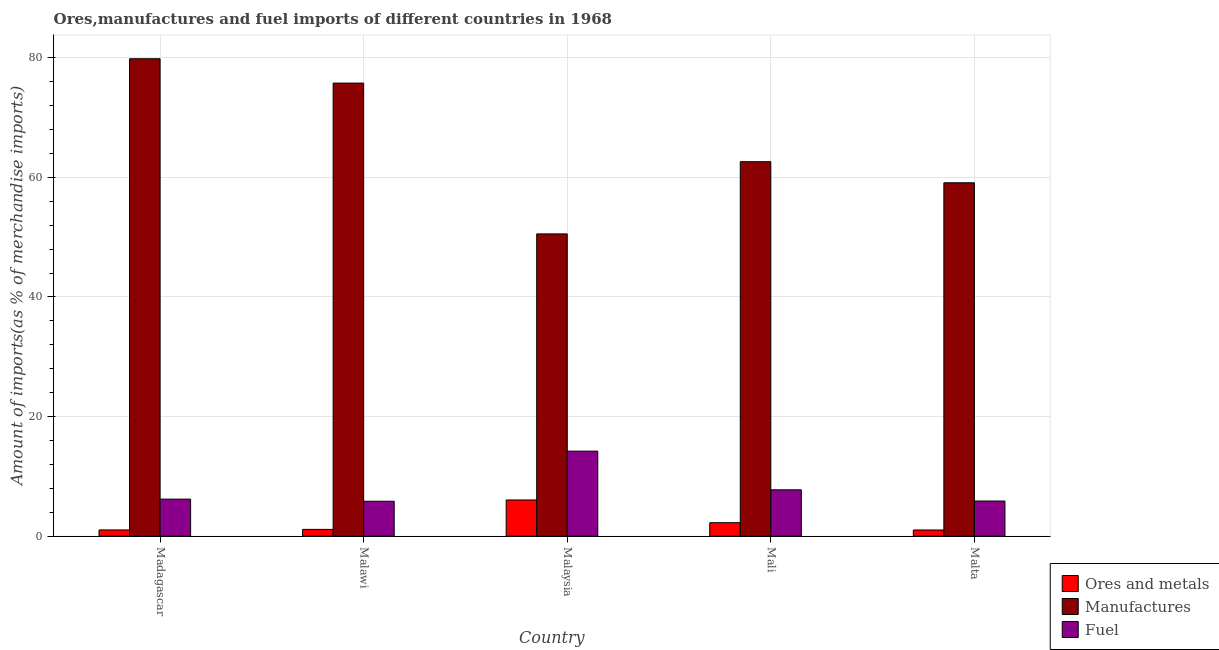How many different coloured bars are there?
Offer a very short reply. 3. How many bars are there on the 2nd tick from the left?
Provide a succinct answer. 3. How many bars are there on the 5th tick from the right?
Keep it short and to the point. 3. What is the label of the 4th group of bars from the left?
Your answer should be compact. Mali. What is the percentage of ores and metals imports in Malawi?
Provide a short and direct response. 1.15. Across all countries, what is the maximum percentage of ores and metals imports?
Your answer should be very brief. 6.06. Across all countries, what is the minimum percentage of ores and metals imports?
Your response must be concise. 1.05. In which country was the percentage of fuel imports maximum?
Make the answer very short. Malaysia. In which country was the percentage of ores and metals imports minimum?
Give a very brief answer. Malta. What is the total percentage of manufactures imports in the graph?
Make the answer very short. 327.84. What is the difference between the percentage of fuel imports in Madagascar and that in Malta?
Provide a short and direct response. 0.32. What is the difference between the percentage of ores and metals imports in Madagascar and the percentage of manufactures imports in Malta?
Ensure brevity in your answer.  -58.04. What is the average percentage of fuel imports per country?
Ensure brevity in your answer.  7.99. What is the difference between the percentage of fuel imports and percentage of manufactures imports in Malta?
Make the answer very short. -53.2. In how many countries, is the percentage of fuel imports greater than 32 %?
Offer a terse response. 0. What is the ratio of the percentage of ores and metals imports in Madagascar to that in Malta?
Offer a very short reply. 1.01. Is the percentage of ores and metals imports in Madagascar less than that in Mali?
Provide a succinct answer. Yes. What is the difference between the highest and the second highest percentage of manufactures imports?
Your response must be concise. 4.07. What is the difference between the highest and the lowest percentage of fuel imports?
Keep it short and to the point. 8.38. In how many countries, is the percentage of ores and metals imports greater than the average percentage of ores and metals imports taken over all countries?
Provide a short and direct response. 1. Is the sum of the percentage of ores and metals imports in Madagascar and Malaysia greater than the maximum percentage of manufactures imports across all countries?
Keep it short and to the point. No. What does the 1st bar from the left in Malawi represents?
Ensure brevity in your answer.  Ores and metals. What does the 3rd bar from the right in Mali represents?
Your answer should be very brief. Ores and metals. Is it the case that in every country, the sum of the percentage of ores and metals imports and percentage of manufactures imports is greater than the percentage of fuel imports?
Offer a terse response. Yes. How many bars are there?
Keep it short and to the point. 15. Are all the bars in the graph horizontal?
Provide a succinct answer. No. How many countries are there in the graph?
Offer a terse response. 5. Does the graph contain grids?
Your response must be concise. Yes. How are the legend labels stacked?
Make the answer very short. Vertical. What is the title of the graph?
Your answer should be very brief. Ores,manufactures and fuel imports of different countries in 1968. What is the label or title of the Y-axis?
Provide a short and direct response. Amount of imports(as % of merchandise imports). What is the Amount of imports(as % of merchandise imports) of Ores and metals in Madagascar?
Provide a short and direct response. 1.06. What is the Amount of imports(as % of merchandise imports) in Manufactures in Madagascar?
Ensure brevity in your answer.  79.83. What is the Amount of imports(as % of merchandise imports) in Fuel in Madagascar?
Offer a very short reply. 6.21. What is the Amount of imports(as % of merchandise imports) in Ores and metals in Malawi?
Give a very brief answer. 1.15. What is the Amount of imports(as % of merchandise imports) of Manufactures in Malawi?
Provide a short and direct response. 75.76. What is the Amount of imports(as % of merchandise imports) of Fuel in Malawi?
Provide a short and direct response. 5.85. What is the Amount of imports(as % of merchandise imports) of Ores and metals in Malaysia?
Offer a terse response. 6.06. What is the Amount of imports(as % of merchandise imports) in Manufactures in Malaysia?
Ensure brevity in your answer.  50.55. What is the Amount of imports(as % of merchandise imports) in Fuel in Malaysia?
Offer a very short reply. 14.23. What is the Amount of imports(as % of merchandise imports) in Ores and metals in Mali?
Your answer should be very brief. 2.27. What is the Amount of imports(as % of merchandise imports) of Manufactures in Mali?
Your answer should be very brief. 62.62. What is the Amount of imports(as % of merchandise imports) in Fuel in Mali?
Offer a very short reply. 7.76. What is the Amount of imports(as % of merchandise imports) of Ores and metals in Malta?
Give a very brief answer. 1.05. What is the Amount of imports(as % of merchandise imports) of Manufactures in Malta?
Your answer should be compact. 59.09. What is the Amount of imports(as % of merchandise imports) of Fuel in Malta?
Your response must be concise. 5.89. Across all countries, what is the maximum Amount of imports(as % of merchandise imports) of Ores and metals?
Give a very brief answer. 6.06. Across all countries, what is the maximum Amount of imports(as % of merchandise imports) of Manufactures?
Give a very brief answer. 79.83. Across all countries, what is the maximum Amount of imports(as % of merchandise imports) of Fuel?
Offer a very short reply. 14.23. Across all countries, what is the minimum Amount of imports(as % of merchandise imports) of Ores and metals?
Your answer should be compact. 1.05. Across all countries, what is the minimum Amount of imports(as % of merchandise imports) in Manufactures?
Offer a terse response. 50.55. Across all countries, what is the minimum Amount of imports(as % of merchandise imports) in Fuel?
Provide a succinct answer. 5.85. What is the total Amount of imports(as % of merchandise imports) in Ores and metals in the graph?
Your answer should be very brief. 11.58. What is the total Amount of imports(as % of merchandise imports) in Manufactures in the graph?
Your response must be concise. 327.84. What is the total Amount of imports(as % of merchandise imports) of Fuel in the graph?
Your answer should be compact. 39.94. What is the difference between the Amount of imports(as % of merchandise imports) of Ores and metals in Madagascar and that in Malawi?
Offer a terse response. -0.09. What is the difference between the Amount of imports(as % of merchandise imports) of Manufactures in Madagascar and that in Malawi?
Give a very brief answer. 4.07. What is the difference between the Amount of imports(as % of merchandise imports) of Fuel in Madagascar and that in Malawi?
Ensure brevity in your answer.  0.36. What is the difference between the Amount of imports(as % of merchandise imports) of Ores and metals in Madagascar and that in Malaysia?
Offer a very short reply. -5.01. What is the difference between the Amount of imports(as % of merchandise imports) in Manufactures in Madagascar and that in Malaysia?
Your answer should be very brief. 29.28. What is the difference between the Amount of imports(as % of merchandise imports) in Fuel in Madagascar and that in Malaysia?
Ensure brevity in your answer.  -8.02. What is the difference between the Amount of imports(as % of merchandise imports) of Ores and metals in Madagascar and that in Mali?
Provide a succinct answer. -1.21. What is the difference between the Amount of imports(as % of merchandise imports) of Manufactures in Madagascar and that in Mali?
Your answer should be compact. 17.21. What is the difference between the Amount of imports(as % of merchandise imports) of Fuel in Madagascar and that in Mali?
Your answer should be compact. -1.55. What is the difference between the Amount of imports(as % of merchandise imports) of Ores and metals in Madagascar and that in Malta?
Make the answer very short. 0.01. What is the difference between the Amount of imports(as % of merchandise imports) of Manufactures in Madagascar and that in Malta?
Give a very brief answer. 20.73. What is the difference between the Amount of imports(as % of merchandise imports) in Fuel in Madagascar and that in Malta?
Give a very brief answer. 0.32. What is the difference between the Amount of imports(as % of merchandise imports) in Ores and metals in Malawi and that in Malaysia?
Offer a terse response. -4.92. What is the difference between the Amount of imports(as % of merchandise imports) of Manufactures in Malawi and that in Malaysia?
Offer a terse response. 25.21. What is the difference between the Amount of imports(as % of merchandise imports) of Fuel in Malawi and that in Malaysia?
Provide a short and direct response. -8.38. What is the difference between the Amount of imports(as % of merchandise imports) in Ores and metals in Malawi and that in Mali?
Give a very brief answer. -1.12. What is the difference between the Amount of imports(as % of merchandise imports) in Manufactures in Malawi and that in Mali?
Give a very brief answer. 13.14. What is the difference between the Amount of imports(as % of merchandise imports) of Fuel in Malawi and that in Mali?
Offer a terse response. -1.91. What is the difference between the Amount of imports(as % of merchandise imports) of Ores and metals in Malawi and that in Malta?
Provide a short and direct response. 0.1. What is the difference between the Amount of imports(as % of merchandise imports) in Manufactures in Malawi and that in Malta?
Offer a terse response. 16.66. What is the difference between the Amount of imports(as % of merchandise imports) in Fuel in Malawi and that in Malta?
Offer a very short reply. -0.04. What is the difference between the Amount of imports(as % of merchandise imports) of Ores and metals in Malaysia and that in Mali?
Provide a short and direct response. 3.8. What is the difference between the Amount of imports(as % of merchandise imports) in Manufactures in Malaysia and that in Mali?
Your answer should be very brief. -12.07. What is the difference between the Amount of imports(as % of merchandise imports) in Fuel in Malaysia and that in Mali?
Give a very brief answer. 6.47. What is the difference between the Amount of imports(as % of merchandise imports) of Ores and metals in Malaysia and that in Malta?
Offer a very short reply. 5.02. What is the difference between the Amount of imports(as % of merchandise imports) in Manufactures in Malaysia and that in Malta?
Keep it short and to the point. -8.55. What is the difference between the Amount of imports(as % of merchandise imports) of Fuel in Malaysia and that in Malta?
Your answer should be compact. 8.34. What is the difference between the Amount of imports(as % of merchandise imports) in Ores and metals in Mali and that in Malta?
Provide a succinct answer. 1.22. What is the difference between the Amount of imports(as % of merchandise imports) of Manufactures in Mali and that in Malta?
Provide a succinct answer. 3.52. What is the difference between the Amount of imports(as % of merchandise imports) of Fuel in Mali and that in Malta?
Keep it short and to the point. 1.87. What is the difference between the Amount of imports(as % of merchandise imports) of Ores and metals in Madagascar and the Amount of imports(as % of merchandise imports) of Manufactures in Malawi?
Give a very brief answer. -74.7. What is the difference between the Amount of imports(as % of merchandise imports) of Ores and metals in Madagascar and the Amount of imports(as % of merchandise imports) of Fuel in Malawi?
Your answer should be compact. -4.79. What is the difference between the Amount of imports(as % of merchandise imports) of Manufactures in Madagascar and the Amount of imports(as % of merchandise imports) of Fuel in Malawi?
Your answer should be compact. 73.98. What is the difference between the Amount of imports(as % of merchandise imports) of Ores and metals in Madagascar and the Amount of imports(as % of merchandise imports) of Manufactures in Malaysia?
Your answer should be compact. -49.49. What is the difference between the Amount of imports(as % of merchandise imports) in Ores and metals in Madagascar and the Amount of imports(as % of merchandise imports) in Fuel in Malaysia?
Provide a short and direct response. -13.17. What is the difference between the Amount of imports(as % of merchandise imports) in Manufactures in Madagascar and the Amount of imports(as % of merchandise imports) in Fuel in Malaysia?
Your answer should be compact. 65.6. What is the difference between the Amount of imports(as % of merchandise imports) in Ores and metals in Madagascar and the Amount of imports(as % of merchandise imports) in Manufactures in Mali?
Your answer should be compact. -61.56. What is the difference between the Amount of imports(as % of merchandise imports) of Ores and metals in Madagascar and the Amount of imports(as % of merchandise imports) of Fuel in Mali?
Provide a succinct answer. -6.7. What is the difference between the Amount of imports(as % of merchandise imports) of Manufactures in Madagascar and the Amount of imports(as % of merchandise imports) of Fuel in Mali?
Provide a short and direct response. 72.07. What is the difference between the Amount of imports(as % of merchandise imports) in Ores and metals in Madagascar and the Amount of imports(as % of merchandise imports) in Manufactures in Malta?
Provide a short and direct response. -58.04. What is the difference between the Amount of imports(as % of merchandise imports) in Ores and metals in Madagascar and the Amount of imports(as % of merchandise imports) in Fuel in Malta?
Provide a short and direct response. -4.83. What is the difference between the Amount of imports(as % of merchandise imports) of Manufactures in Madagascar and the Amount of imports(as % of merchandise imports) of Fuel in Malta?
Ensure brevity in your answer.  73.94. What is the difference between the Amount of imports(as % of merchandise imports) of Ores and metals in Malawi and the Amount of imports(as % of merchandise imports) of Manufactures in Malaysia?
Provide a succinct answer. -49.4. What is the difference between the Amount of imports(as % of merchandise imports) of Ores and metals in Malawi and the Amount of imports(as % of merchandise imports) of Fuel in Malaysia?
Your response must be concise. -13.08. What is the difference between the Amount of imports(as % of merchandise imports) in Manufactures in Malawi and the Amount of imports(as % of merchandise imports) in Fuel in Malaysia?
Keep it short and to the point. 61.53. What is the difference between the Amount of imports(as % of merchandise imports) in Ores and metals in Malawi and the Amount of imports(as % of merchandise imports) in Manufactures in Mali?
Keep it short and to the point. -61.47. What is the difference between the Amount of imports(as % of merchandise imports) of Ores and metals in Malawi and the Amount of imports(as % of merchandise imports) of Fuel in Mali?
Ensure brevity in your answer.  -6.62. What is the difference between the Amount of imports(as % of merchandise imports) of Manufactures in Malawi and the Amount of imports(as % of merchandise imports) of Fuel in Mali?
Make the answer very short. 68. What is the difference between the Amount of imports(as % of merchandise imports) of Ores and metals in Malawi and the Amount of imports(as % of merchandise imports) of Manufactures in Malta?
Give a very brief answer. -57.95. What is the difference between the Amount of imports(as % of merchandise imports) of Ores and metals in Malawi and the Amount of imports(as % of merchandise imports) of Fuel in Malta?
Offer a very short reply. -4.74. What is the difference between the Amount of imports(as % of merchandise imports) of Manufactures in Malawi and the Amount of imports(as % of merchandise imports) of Fuel in Malta?
Your response must be concise. 69.87. What is the difference between the Amount of imports(as % of merchandise imports) of Ores and metals in Malaysia and the Amount of imports(as % of merchandise imports) of Manufactures in Mali?
Keep it short and to the point. -56.55. What is the difference between the Amount of imports(as % of merchandise imports) in Ores and metals in Malaysia and the Amount of imports(as % of merchandise imports) in Fuel in Mali?
Provide a short and direct response. -1.7. What is the difference between the Amount of imports(as % of merchandise imports) of Manufactures in Malaysia and the Amount of imports(as % of merchandise imports) of Fuel in Mali?
Provide a succinct answer. 42.78. What is the difference between the Amount of imports(as % of merchandise imports) of Ores and metals in Malaysia and the Amount of imports(as % of merchandise imports) of Manufactures in Malta?
Provide a short and direct response. -53.03. What is the difference between the Amount of imports(as % of merchandise imports) of Ores and metals in Malaysia and the Amount of imports(as % of merchandise imports) of Fuel in Malta?
Provide a short and direct response. 0.17. What is the difference between the Amount of imports(as % of merchandise imports) of Manufactures in Malaysia and the Amount of imports(as % of merchandise imports) of Fuel in Malta?
Your answer should be very brief. 44.66. What is the difference between the Amount of imports(as % of merchandise imports) of Ores and metals in Mali and the Amount of imports(as % of merchandise imports) of Manufactures in Malta?
Make the answer very short. -56.83. What is the difference between the Amount of imports(as % of merchandise imports) of Ores and metals in Mali and the Amount of imports(as % of merchandise imports) of Fuel in Malta?
Keep it short and to the point. -3.62. What is the difference between the Amount of imports(as % of merchandise imports) in Manufactures in Mali and the Amount of imports(as % of merchandise imports) in Fuel in Malta?
Provide a short and direct response. 56.73. What is the average Amount of imports(as % of merchandise imports) of Ores and metals per country?
Provide a succinct answer. 2.32. What is the average Amount of imports(as % of merchandise imports) in Manufactures per country?
Your response must be concise. 65.57. What is the average Amount of imports(as % of merchandise imports) of Fuel per country?
Your answer should be compact. 7.99. What is the difference between the Amount of imports(as % of merchandise imports) in Ores and metals and Amount of imports(as % of merchandise imports) in Manufactures in Madagascar?
Offer a terse response. -78.77. What is the difference between the Amount of imports(as % of merchandise imports) in Ores and metals and Amount of imports(as % of merchandise imports) in Fuel in Madagascar?
Your answer should be very brief. -5.15. What is the difference between the Amount of imports(as % of merchandise imports) of Manufactures and Amount of imports(as % of merchandise imports) of Fuel in Madagascar?
Provide a short and direct response. 73.62. What is the difference between the Amount of imports(as % of merchandise imports) of Ores and metals and Amount of imports(as % of merchandise imports) of Manufactures in Malawi?
Your answer should be compact. -74.61. What is the difference between the Amount of imports(as % of merchandise imports) in Ores and metals and Amount of imports(as % of merchandise imports) in Fuel in Malawi?
Keep it short and to the point. -4.71. What is the difference between the Amount of imports(as % of merchandise imports) of Manufactures and Amount of imports(as % of merchandise imports) of Fuel in Malawi?
Your answer should be very brief. 69.91. What is the difference between the Amount of imports(as % of merchandise imports) in Ores and metals and Amount of imports(as % of merchandise imports) in Manufactures in Malaysia?
Your answer should be compact. -44.48. What is the difference between the Amount of imports(as % of merchandise imports) of Ores and metals and Amount of imports(as % of merchandise imports) of Fuel in Malaysia?
Offer a very short reply. -8.16. What is the difference between the Amount of imports(as % of merchandise imports) in Manufactures and Amount of imports(as % of merchandise imports) in Fuel in Malaysia?
Ensure brevity in your answer.  36.32. What is the difference between the Amount of imports(as % of merchandise imports) in Ores and metals and Amount of imports(as % of merchandise imports) in Manufactures in Mali?
Your response must be concise. -60.35. What is the difference between the Amount of imports(as % of merchandise imports) of Ores and metals and Amount of imports(as % of merchandise imports) of Fuel in Mali?
Your answer should be compact. -5.5. What is the difference between the Amount of imports(as % of merchandise imports) in Manufactures and Amount of imports(as % of merchandise imports) in Fuel in Mali?
Offer a terse response. 54.86. What is the difference between the Amount of imports(as % of merchandise imports) in Ores and metals and Amount of imports(as % of merchandise imports) in Manufactures in Malta?
Give a very brief answer. -58.05. What is the difference between the Amount of imports(as % of merchandise imports) of Ores and metals and Amount of imports(as % of merchandise imports) of Fuel in Malta?
Provide a short and direct response. -4.84. What is the difference between the Amount of imports(as % of merchandise imports) of Manufactures and Amount of imports(as % of merchandise imports) of Fuel in Malta?
Make the answer very short. 53.2. What is the ratio of the Amount of imports(as % of merchandise imports) in Ores and metals in Madagascar to that in Malawi?
Offer a terse response. 0.92. What is the ratio of the Amount of imports(as % of merchandise imports) in Manufactures in Madagascar to that in Malawi?
Make the answer very short. 1.05. What is the ratio of the Amount of imports(as % of merchandise imports) in Fuel in Madagascar to that in Malawi?
Give a very brief answer. 1.06. What is the ratio of the Amount of imports(as % of merchandise imports) of Ores and metals in Madagascar to that in Malaysia?
Provide a succinct answer. 0.17. What is the ratio of the Amount of imports(as % of merchandise imports) in Manufactures in Madagascar to that in Malaysia?
Keep it short and to the point. 1.58. What is the ratio of the Amount of imports(as % of merchandise imports) of Fuel in Madagascar to that in Malaysia?
Offer a terse response. 0.44. What is the ratio of the Amount of imports(as % of merchandise imports) in Ores and metals in Madagascar to that in Mali?
Provide a succinct answer. 0.47. What is the ratio of the Amount of imports(as % of merchandise imports) of Manufactures in Madagascar to that in Mali?
Your response must be concise. 1.27. What is the ratio of the Amount of imports(as % of merchandise imports) of Ores and metals in Madagascar to that in Malta?
Provide a short and direct response. 1.01. What is the ratio of the Amount of imports(as % of merchandise imports) of Manufactures in Madagascar to that in Malta?
Your answer should be very brief. 1.35. What is the ratio of the Amount of imports(as % of merchandise imports) in Fuel in Madagascar to that in Malta?
Your answer should be very brief. 1.05. What is the ratio of the Amount of imports(as % of merchandise imports) in Ores and metals in Malawi to that in Malaysia?
Provide a succinct answer. 0.19. What is the ratio of the Amount of imports(as % of merchandise imports) in Manufactures in Malawi to that in Malaysia?
Your response must be concise. 1.5. What is the ratio of the Amount of imports(as % of merchandise imports) of Fuel in Malawi to that in Malaysia?
Offer a terse response. 0.41. What is the ratio of the Amount of imports(as % of merchandise imports) of Ores and metals in Malawi to that in Mali?
Offer a very short reply. 0.51. What is the ratio of the Amount of imports(as % of merchandise imports) in Manufactures in Malawi to that in Mali?
Ensure brevity in your answer.  1.21. What is the ratio of the Amount of imports(as % of merchandise imports) in Fuel in Malawi to that in Mali?
Give a very brief answer. 0.75. What is the ratio of the Amount of imports(as % of merchandise imports) of Ores and metals in Malawi to that in Malta?
Keep it short and to the point. 1.1. What is the ratio of the Amount of imports(as % of merchandise imports) of Manufactures in Malawi to that in Malta?
Provide a succinct answer. 1.28. What is the ratio of the Amount of imports(as % of merchandise imports) of Ores and metals in Malaysia to that in Mali?
Your response must be concise. 2.68. What is the ratio of the Amount of imports(as % of merchandise imports) in Manufactures in Malaysia to that in Mali?
Ensure brevity in your answer.  0.81. What is the ratio of the Amount of imports(as % of merchandise imports) in Fuel in Malaysia to that in Mali?
Offer a terse response. 1.83. What is the ratio of the Amount of imports(as % of merchandise imports) of Ores and metals in Malaysia to that in Malta?
Your response must be concise. 5.8. What is the ratio of the Amount of imports(as % of merchandise imports) in Manufactures in Malaysia to that in Malta?
Your response must be concise. 0.86. What is the ratio of the Amount of imports(as % of merchandise imports) of Fuel in Malaysia to that in Malta?
Give a very brief answer. 2.42. What is the ratio of the Amount of imports(as % of merchandise imports) in Ores and metals in Mali to that in Malta?
Keep it short and to the point. 2.17. What is the ratio of the Amount of imports(as % of merchandise imports) of Manufactures in Mali to that in Malta?
Provide a short and direct response. 1.06. What is the ratio of the Amount of imports(as % of merchandise imports) of Fuel in Mali to that in Malta?
Provide a short and direct response. 1.32. What is the difference between the highest and the second highest Amount of imports(as % of merchandise imports) in Ores and metals?
Your answer should be compact. 3.8. What is the difference between the highest and the second highest Amount of imports(as % of merchandise imports) of Manufactures?
Give a very brief answer. 4.07. What is the difference between the highest and the second highest Amount of imports(as % of merchandise imports) in Fuel?
Your response must be concise. 6.47. What is the difference between the highest and the lowest Amount of imports(as % of merchandise imports) in Ores and metals?
Give a very brief answer. 5.02. What is the difference between the highest and the lowest Amount of imports(as % of merchandise imports) in Manufactures?
Make the answer very short. 29.28. What is the difference between the highest and the lowest Amount of imports(as % of merchandise imports) in Fuel?
Provide a succinct answer. 8.38. 